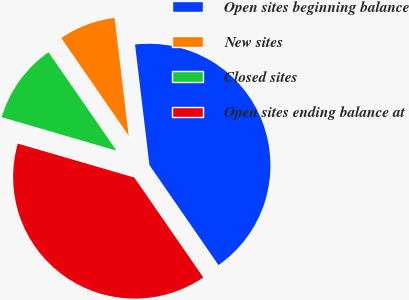Convert chart to OTSL. <chart><loc_0><loc_0><loc_500><loc_500><pie_chart><fcel>Open sites beginning balance<fcel>New sites<fcel>Closed sites<fcel>Open sites ending balance at<nl><fcel>42.28%<fcel>7.72%<fcel>10.87%<fcel>39.13%<nl></chart> 